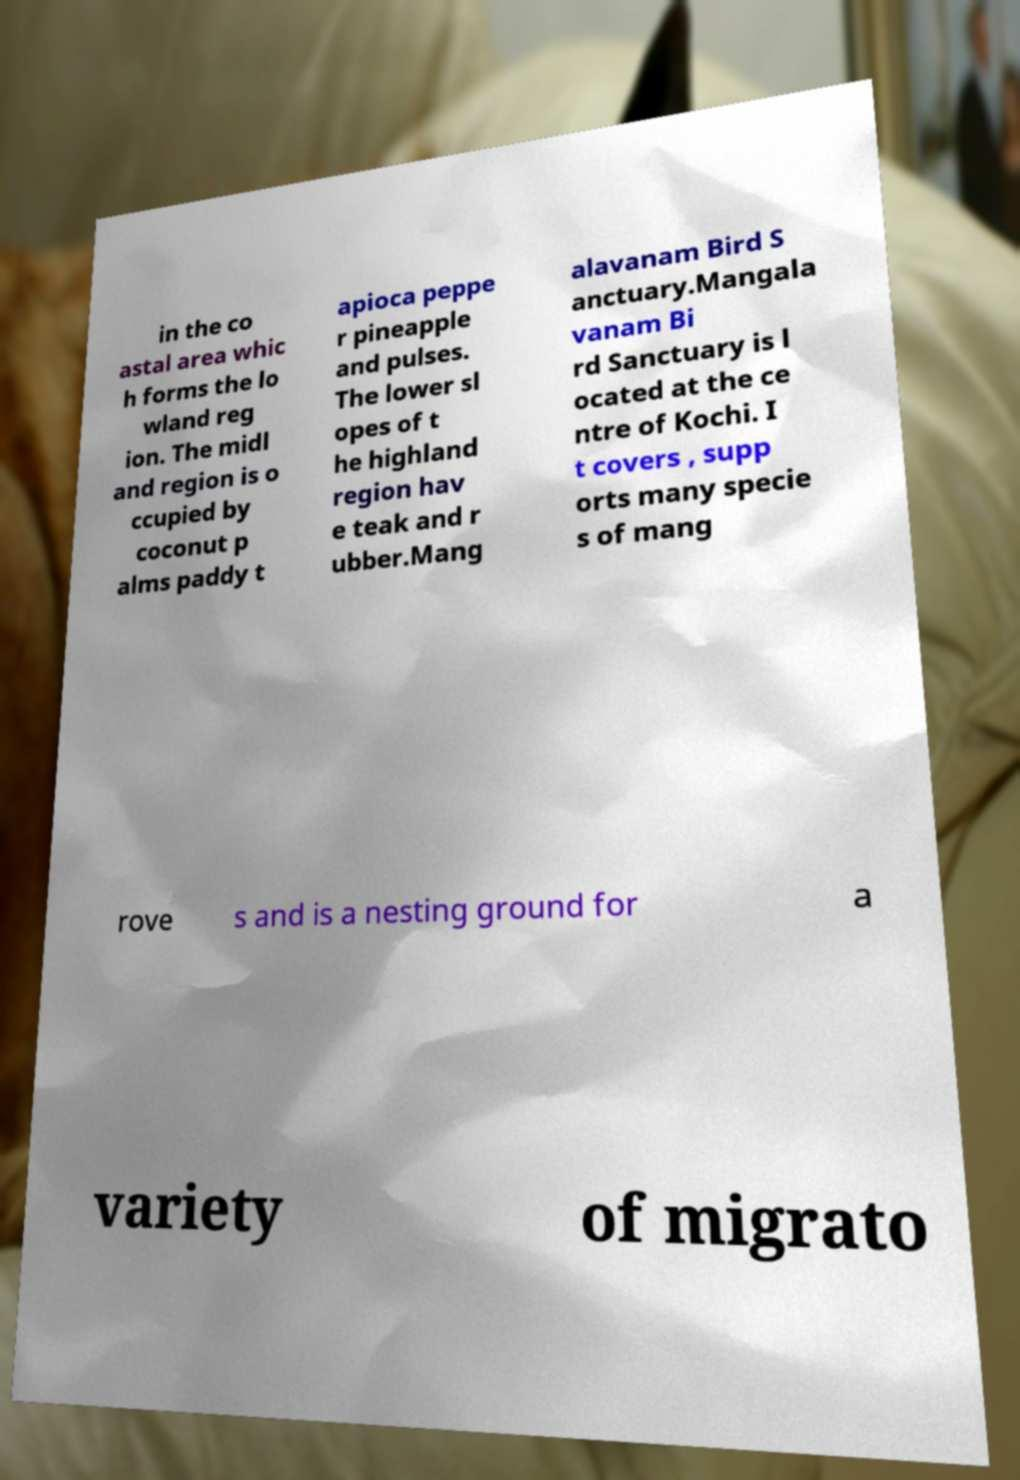For documentation purposes, I need the text within this image transcribed. Could you provide that? in the co astal area whic h forms the lo wland reg ion. The midl and region is o ccupied by coconut p alms paddy t apioca peppe r pineapple and pulses. The lower sl opes of t he highland region hav e teak and r ubber.Mang alavanam Bird S anctuary.Mangala vanam Bi rd Sanctuary is l ocated at the ce ntre of Kochi. I t covers , supp orts many specie s of mang rove s and is a nesting ground for a variety of migrato 